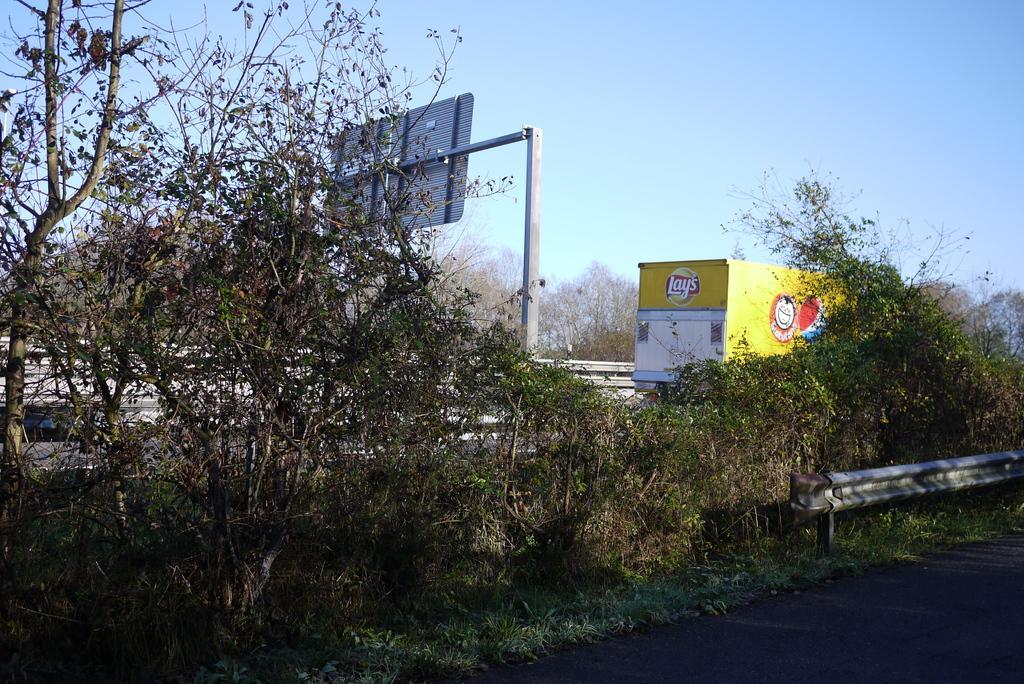In one or two sentences, can you explain what this image depicts? In this image at the bottom we can see road, small fence, plants and grass on the ground. In the background we can see a vehicle, board on a pole stand, fence, trees and sky. 